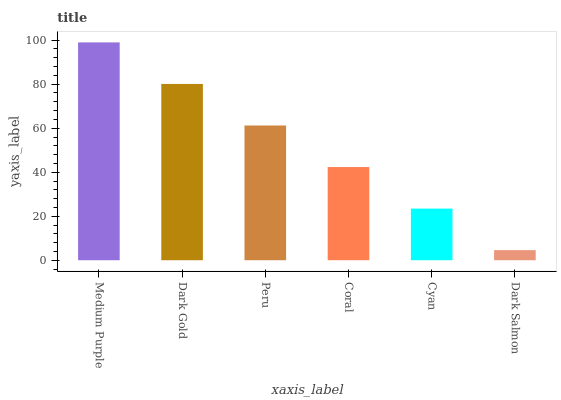Is Dark Salmon the minimum?
Answer yes or no. Yes. Is Medium Purple the maximum?
Answer yes or no. Yes. Is Dark Gold the minimum?
Answer yes or no. No. Is Dark Gold the maximum?
Answer yes or no. No. Is Medium Purple greater than Dark Gold?
Answer yes or no. Yes. Is Dark Gold less than Medium Purple?
Answer yes or no. Yes. Is Dark Gold greater than Medium Purple?
Answer yes or no. No. Is Medium Purple less than Dark Gold?
Answer yes or no. No. Is Peru the high median?
Answer yes or no. Yes. Is Coral the low median?
Answer yes or no. Yes. Is Dark Gold the high median?
Answer yes or no. No. Is Dark Gold the low median?
Answer yes or no. No. 